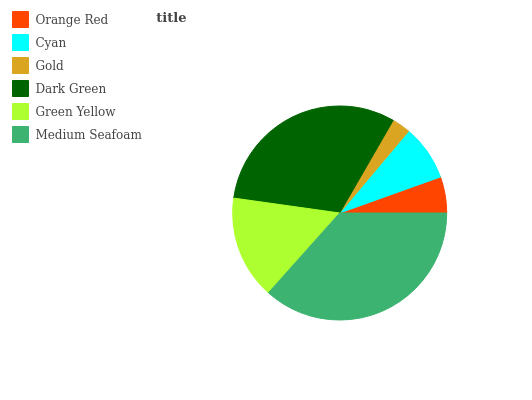Is Gold the minimum?
Answer yes or no. Yes. Is Medium Seafoam the maximum?
Answer yes or no. Yes. Is Cyan the minimum?
Answer yes or no. No. Is Cyan the maximum?
Answer yes or no. No. Is Cyan greater than Orange Red?
Answer yes or no. Yes. Is Orange Red less than Cyan?
Answer yes or no. Yes. Is Orange Red greater than Cyan?
Answer yes or no. No. Is Cyan less than Orange Red?
Answer yes or no. No. Is Green Yellow the high median?
Answer yes or no. Yes. Is Cyan the low median?
Answer yes or no. Yes. Is Cyan the high median?
Answer yes or no. No. Is Green Yellow the low median?
Answer yes or no. No. 